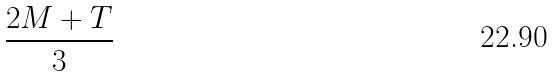<formula> <loc_0><loc_0><loc_500><loc_500>\frac { 2 M + T } { 3 }</formula> 